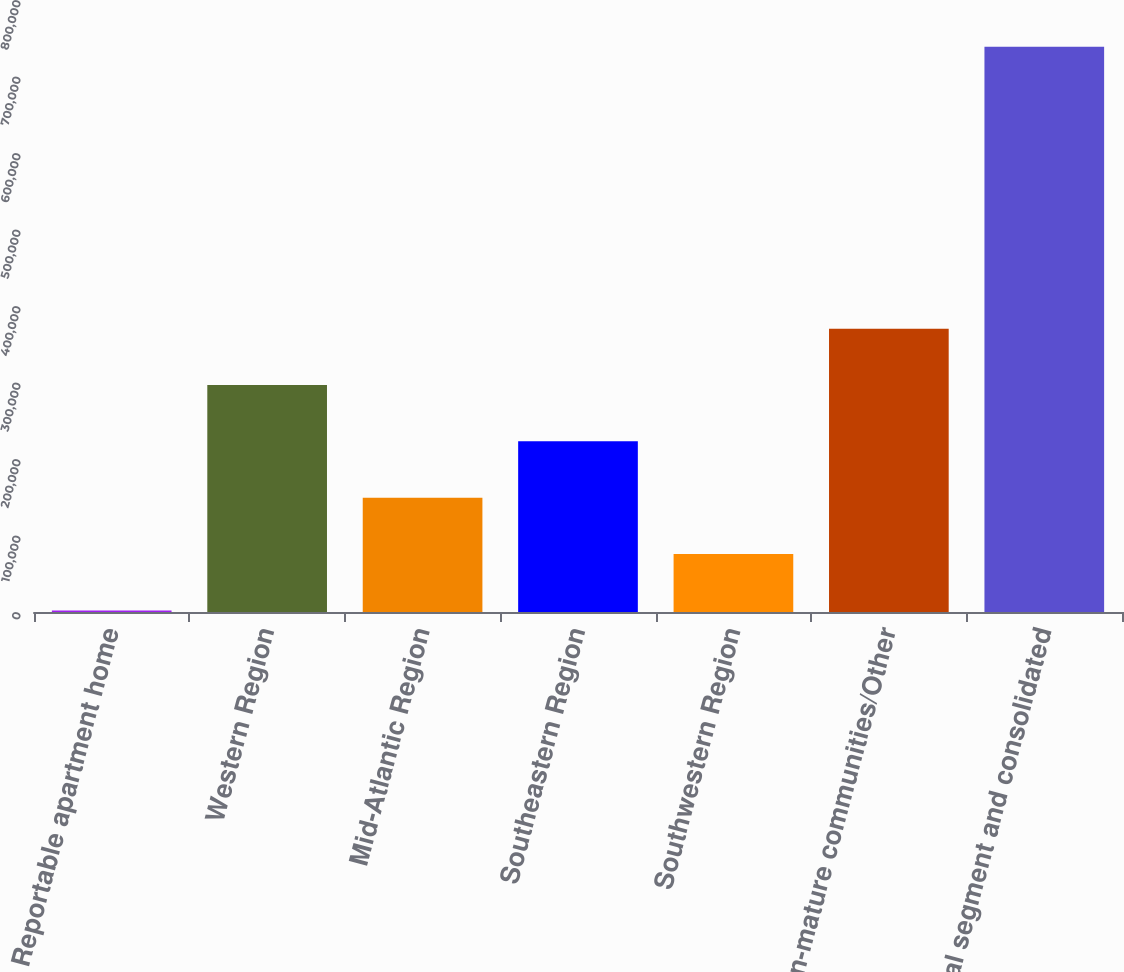Convert chart. <chart><loc_0><loc_0><loc_500><loc_500><bar_chart><fcel>Reportable apartment home<fcel>Western Region<fcel>Mid-Atlantic Region<fcel>Southeastern Region<fcel>Southwestern Region<fcel>Non-mature communities/Other<fcel>Total segment and consolidated<nl><fcel>2007<fcel>296730<fcel>149368<fcel>223049<fcel>75687.7<fcel>370410<fcel>738814<nl></chart> 